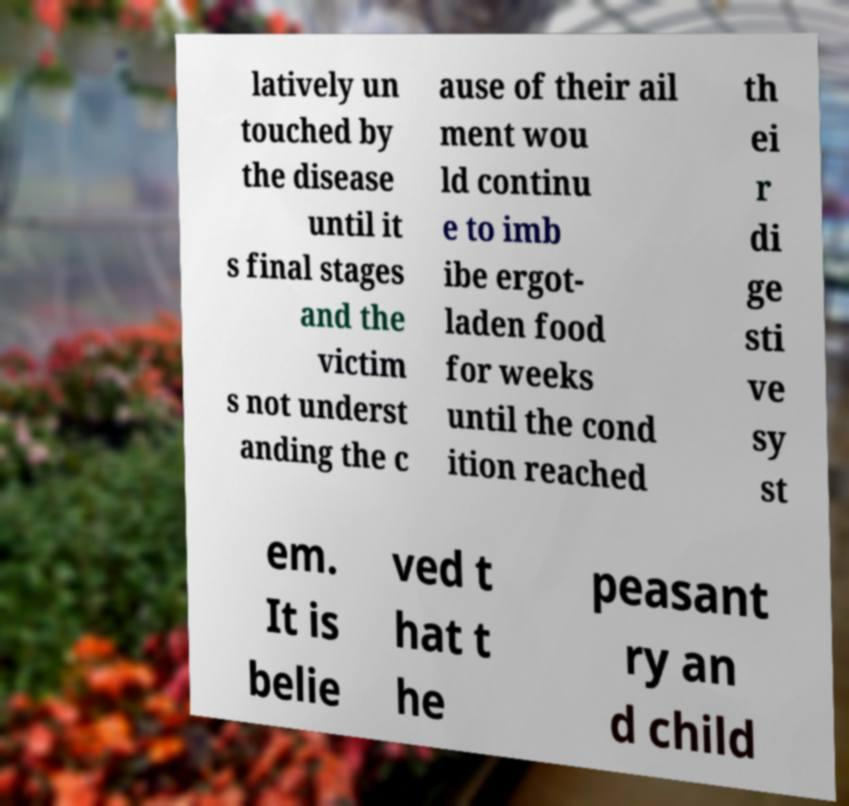There's text embedded in this image that I need extracted. Can you transcribe it verbatim? latively un touched by the disease until it s final stages and the victim s not underst anding the c ause of their ail ment wou ld continu e to imb ibe ergot- laden food for weeks until the cond ition reached th ei r di ge sti ve sy st em. It is belie ved t hat t he peasant ry an d child 